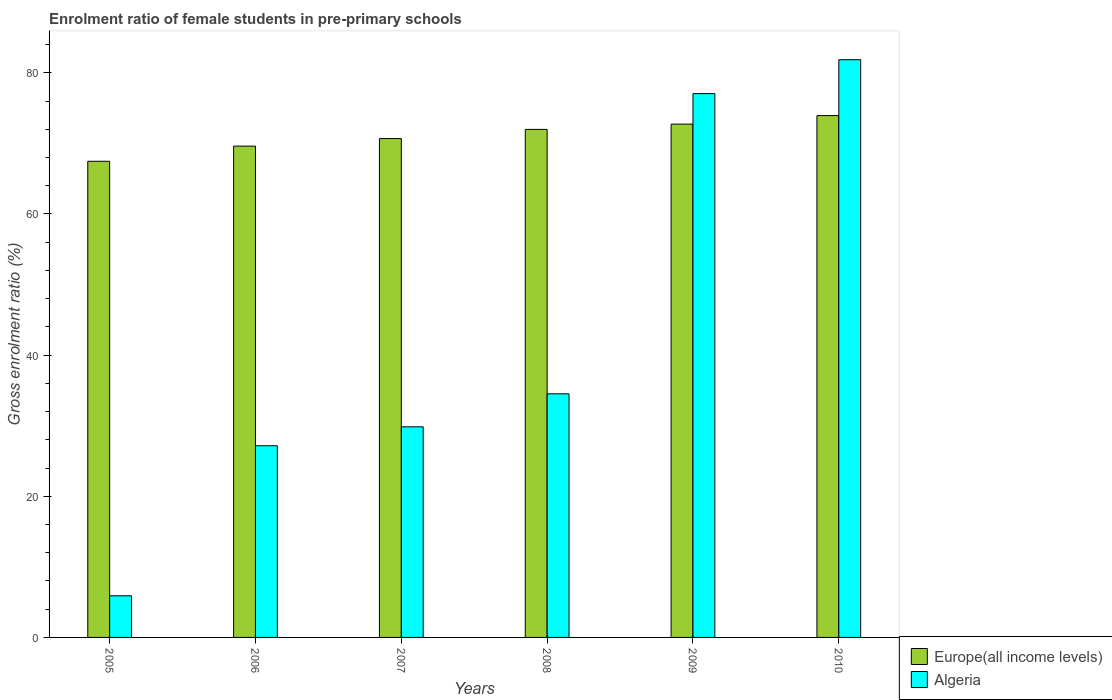How many different coloured bars are there?
Offer a terse response. 2. How many groups of bars are there?
Keep it short and to the point. 6. How many bars are there on the 2nd tick from the right?
Offer a terse response. 2. What is the enrolment ratio of female students in pre-primary schools in Algeria in 2006?
Give a very brief answer. 27.16. Across all years, what is the maximum enrolment ratio of female students in pre-primary schools in Europe(all income levels)?
Make the answer very short. 73.94. Across all years, what is the minimum enrolment ratio of female students in pre-primary schools in Europe(all income levels)?
Your answer should be compact. 67.47. In which year was the enrolment ratio of female students in pre-primary schools in Algeria maximum?
Provide a succinct answer. 2010. In which year was the enrolment ratio of female students in pre-primary schools in Algeria minimum?
Ensure brevity in your answer.  2005. What is the total enrolment ratio of female students in pre-primary schools in Algeria in the graph?
Ensure brevity in your answer.  256.34. What is the difference between the enrolment ratio of female students in pre-primary schools in Europe(all income levels) in 2007 and that in 2008?
Keep it short and to the point. -1.3. What is the difference between the enrolment ratio of female students in pre-primary schools in Europe(all income levels) in 2008 and the enrolment ratio of female students in pre-primary schools in Algeria in 2009?
Make the answer very short. -5.07. What is the average enrolment ratio of female students in pre-primary schools in Europe(all income levels) per year?
Give a very brief answer. 71.07. In the year 2010, what is the difference between the enrolment ratio of female students in pre-primary schools in Algeria and enrolment ratio of female students in pre-primary schools in Europe(all income levels)?
Offer a terse response. 7.92. In how many years, is the enrolment ratio of female students in pre-primary schools in Algeria greater than 8 %?
Offer a terse response. 5. What is the ratio of the enrolment ratio of female students in pre-primary schools in Europe(all income levels) in 2005 to that in 2008?
Your answer should be very brief. 0.94. Is the enrolment ratio of female students in pre-primary schools in Algeria in 2005 less than that in 2007?
Offer a very short reply. Yes. What is the difference between the highest and the second highest enrolment ratio of female students in pre-primary schools in Europe(all income levels)?
Keep it short and to the point. 1.21. What is the difference between the highest and the lowest enrolment ratio of female students in pre-primary schools in Europe(all income levels)?
Provide a short and direct response. 6.47. In how many years, is the enrolment ratio of female students in pre-primary schools in Europe(all income levels) greater than the average enrolment ratio of female students in pre-primary schools in Europe(all income levels) taken over all years?
Make the answer very short. 3. Is the sum of the enrolment ratio of female students in pre-primary schools in Europe(all income levels) in 2005 and 2006 greater than the maximum enrolment ratio of female students in pre-primary schools in Algeria across all years?
Offer a very short reply. Yes. What does the 2nd bar from the left in 2005 represents?
Keep it short and to the point. Algeria. What does the 1st bar from the right in 2006 represents?
Offer a terse response. Algeria. Are all the bars in the graph horizontal?
Make the answer very short. No. What is the difference between two consecutive major ticks on the Y-axis?
Give a very brief answer. 20. Where does the legend appear in the graph?
Your answer should be compact. Bottom right. How are the legend labels stacked?
Offer a very short reply. Vertical. What is the title of the graph?
Offer a very short reply. Enrolment ratio of female students in pre-primary schools. What is the Gross enrolment ratio (%) in Europe(all income levels) in 2005?
Make the answer very short. 67.47. What is the Gross enrolment ratio (%) in Algeria in 2005?
Make the answer very short. 5.9. What is the Gross enrolment ratio (%) in Europe(all income levels) in 2006?
Offer a terse response. 69.62. What is the Gross enrolment ratio (%) in Algeria in 2006?
Your answer should be compact. 27.16. What is the Gross enrolment ratio (%) in Europe(all income levels) in 2007?
Keep it short and to the point. 70.69. What is the Gross enrolment ratio (%) in Algeria in 2007?
Your response must be concise. 29.84. What is the Gross enrolment ratio (%) of Europe(all income levels) in 2008?
Your answer should be very brief. 71.99. What is the Gross enrolment ratio (%) of Algeria in 2008?
Give a very brief answer. 34.52. What is the Gross enrolment ratio (%) in Europe(all income levels) in 2009?
Ensure brevity in your answer.  72.73. What is the Gross enrolment ratio (%) in Algeria in 2009?
Ensure brevity in your answer.  77.06. What is the Gross enrolment ratio (%) in Europe(all income levels) in 2010?
Offer a terse response. 73.94. What is the Gross enrolment ratio (%) in Algeria in 2010?
Keep it short and to the point. 81.86. Across all years, what is the maximum Gross enrolment ratio (%) in Europe(all income levels)?
Ensure brevity in your answer.  73.94. Across all years, what is the maximum Gross enrolment ratio (%) of Algeria?
Provide a short and direct response. 81.86. Across all years, what is the minimum Gross enrolment ratio (%) of Europe(all income levels)?
Your answer should be compact. 67.47. Across all years, what is the minimum Gross enrolment ratio (%) in Algeria?
Make the answer very short. 5.9. What is the total Gross enrolment ratio (%) of Europe(all income levels) in the graph?
Make the answer very short. 426.44. What is the total Gross enrolment ratio (%) of Algeria in the graph?
Give a very brief answer. 256.34. What is the difference between the Gross enrolment ratio (%) in Europe(all income levels) in 2005 and that in 2006?
Keep it short and to the point. -2.15. What is the difference between the Gross enrolment ratio (%) in Algeria in 2005 and that in 2006?
Keep it short and to the point. -21.26. What is the difference between the Gross enrolment ratio (%) in Europe(all income levels) in 2005 and that in 2007?
Offer a terse response. -3.22. What is the difference between the Gross enrolment ratio (%) in Algeria in 2005 and that in 2007?
Provide a succinct answer. -23.95. What is the difference between the Gross enrolment ratio (%) in Europe(all income levels) in 2005 and that in 2008?
Provide a short and direct response. -4.52. What is the difference between the Gross enrolment ratio (%) of Algeria in 2005 and that in 2008?
Ensure brevity in your answer.  -28.62. What is the difference between the Gross enrolment ratio (%) of Europe(all income levels) in 2005 and that in 2009?
Provide a short and direct response. -5.26. What is the difference between the Gross enrolment ratio (%) of Algeria in 2005 and that in 2009?
Offer a terse response. -71.16. What is the difference between the Gross enrolment ratio (%) in Europe(all income levels) in 2005 and that in 2010?
Offer a terse response. -6.47. What is the difference between the Gross enrolment ratio (%) in Algeria in 2005 and that in 2010?
Your answer should be compact. -75.96. What is the difference between the Gross enrolment ratio (%) in Europe(all income levels) in 2006 and that in 2007?
Provide a short and direct response. -1.07. What is the difference between the Gross enrolment ratio (%) in Algeria in 2006 and that in 2007?
Your answer should be compact. -2.68. What is the difference between the Gross enrolment ratio (%) in Europe(all income levels) in 2006 and that in 2008?
Offer a terse response. -2.37. What is the difference between the Gross enrolment ratio (%) in Algeria in 2006 and that in 2008?
Provide a short and direct response. -7.36. What is the difference between the Gross enrolment ratio (%) of Europe(all income levels) in 2006 and that in 2009?
Your answer should be compact. -3.12. What is the difference between the Gross enrolment ratio (%) of Algeria in 2006 and that in 2009?
Your answer should be compact. -49.9. What is the difference between the Gross enrolment ratio (%) of Europe(all income levels) in 2006 and that in 2010?
Ensure brevity in your answer.  -4.33. What is the difference between the Gross enrolment ratio (%) in Algeria in 2006 and that in 2010?
Make the answer very short. -54.7. What is the difference between the Gross enrolment ratio (%) of Europe(all income levels) in 2007 and that in 2008?
Your answer should be compact. -1.3. What is the difference between the Gross enrolment ratio (%) of Algeria in 2007 and that in 2008?
Your response must be concise. -4.67. What is the difference between the Gross enrolment ratio (%) of Europe(all income levels) in 2007 and that in 2009?
Provide a short and direct response. -2.05. What is the difference between the Gross enrolment ratio (%) in Algeria in 2007 and that in 2009?
Your answer should be compact. -47.21. What is the difference between the Gross enrolment ratio (%) in Europe(all income levels) in 2007 and that in 2010?
Give a very brief answer. -3.25. What is the difference between the Gross enrolment ratio (%) of Algeria in 2007 and that in 2010?
Provide a short and direct response. -52.02. What is the difference between the Gross enrolment ratio (%) in Europe(all income levels) in 2008 and that in 2009?
Ensure brevity in your answer.  -0.75. What is the difference between the Gross enrolment ratio (%) of Algeria in 2008 and that in 2009?
Offer a very short reply. -42.54. What is the difference between the Gross enrolment ratio (%) of Europe(all income levels) in 2008 and that in 2010?
Keep it short and to the point. -1.96. What is the difference between the Gross enrolment ratio (%) of Algeria in 2008 and that in 2010?
Your answer should be very brief. -47.34. What is the difference between the Gross enrolment ratio (%) in Europe(all income levels) in 2009 and that in 2010?
Ensure brevity in your answer.  -1.21. What is the difference between the Gross enrolment ratio (%) of Algeria in 2009 and that in 2010?
Offer a terse response. -4.8. What is the difference between the Gross enrolment ratio (%) in Europe(all income levels) in 2005 and the Gross enrolment ratio (%) in Algeria in 2006?
Provide a short and direct response. 40.31. What is the difference between the Gross enrolment ratio (%) in Europe(all income levels) in 2005 and the Gross enrolment ratio (%) in Algeria in 2007?
Make the answer very short. 37.63. What is the difference between the Gross enrolment ratio (%) in Europe(all income levels) in 2005 and the Gross enrolment ratio (%) in Algeria in 2008?
Your response must be concise. 32.95. What is the difference between the Gross enrolment ratio (%) in Europe(all income levels) in 2005 and the Gross enrolment ratio (%) in Algeria in 2009?
Make the answer very short. -9.59. What is the difference between the Gross enrolment ratio (%) of Europe(all income levels) in 2005 and the Gross enrolment ratio (%) of Algeria in 2010?
Your answer should be compact. -14.39. What is the difference between the Gross enrolment ratio (%) in Europe(all income levels) in 2006 and the Gross enrolment ratio (%) in Algeria in 2007?
Provide a short and direct response. 39.77. What is the difference between the Gross enrolment ratio (%) of Europe(all income levels) in 2006 and the Gross enrolment ratio (%) of Algeria in 2008?
Your answer should be very brief. 35.1. What is the difference between the Gross enrolment ratio (%) in Europe(all income levels) in 2006 and the Gross enrolment ratio (%) in Algeria in 2009?
Provide a succinct answer. -7.44. What is the difference between the Gross enrolment ratio (%) of Europe(all income levels) in 2006 and the Gross enrolment ratio (%) of Algeria in 2010?
Keep it short and to the point. -12.24. What is the difference between the Gross enrolment ratio (%) of Europe(all income levels) in 2007 and the Gross enrolment ratio (%) of Algeria in 2008?
Offer a very short reply. 36.17. What is the difference between the Gross enrolment ratio (%) of Europe(all income levels) in 2007 and the Gross enrolment ratio (%) of Algeria in 2009?
Offer a terse response. -6.37. What is the difference between the Gross enrolment ratio (%) in Europe(all income levels) in 2007 and the Gross enrolment ratio (%) in Algeria in 2010?
Your response must be concise. -11.17. What is the difference between the Gross enrolment ratio (%) of Europe(all income levels) in 2008 and the Gross enrolment ratio (%) of Algeria in 2009?
Your answer should be compact. -5.07. What is the difference between the Gross enrolment ratio (%) of Europe(all income levels) in 2008 and the Gross enrolment ratio (%) of Algeria in 2010?
Offer a very short reply. -9.88. What is the difference between the Gross enrolment ratio (%) of Europe(all income levels) in 2009 and the Gross enrolment ratio (%) of Algeria in 2010?
Your answer should be very brief. -9.13. What is the average Gross enrolment ratio (%) of Europe(all income levels) per year?
Keep it short and to the point. 71.07. What is the average Gross enrolment ratio (%) of Algeria per year?
Your response must be concise. 42.72. In the year 2005, what is the difference between the Gross enrolment ratio (%) in Europe(all income levels) and Gross enrolment ratio (%) in Algeria?
Your answer should be compact. 61.57. In the year 2006, what is the difference between the Gross enrolment ratio (%) in Europe(all income levels) and Gross enrolment ratio (%) in Algeria?
Give a very brief answer. 42.46. In the year 2007, what is the difference between the Gross enrolment ratio (%) of Europe(all income levels) and Gross enrolment ratio (%) of Algeria?
Make the answer very short. 40.84. In the year 2008, what is the difference between the Gross enrolment ratio (%) in Europe(all income levels) and Gross enrolment ratio (%) in Algeria?
Ensure brevity in your answer.  37.47. In the year 2009, what is the difference between the Gross enrolment ratio (%) of Europe(all income levels) and Gross enrolment ratio (%) of Algeria?
Offer a terse response. -4.32. In the year 2010, what is the difference between the Gross enrolment ratio (%) in Europe(all income levels) and Gross enrolment ratio (%) in Algeria?
Offer a very short reply. -7.92. What is the ratio of the Gross enrolment ratio (%) of Europe(all income levels) in 2005 to that in 2006?
Give a very brief answer. 0.97. What is the ratio of the Gross enrolment ratio (%) of Algeria in 2005 to that in 2006?
Ensure brevity in your answer.  0.22. What is the ratio of the Gross enrolment ratio (%) in Europe(all income levels) in 2005 to that in 2007?
Provide a short and direct response. 0.95. What is the ratio of the Gross enrolment ratio (%) of Algeria in 2005 to that in 2007?
Your answer should be compact. 0.2. What is the ratio of the Gross enrolment ratio (%) of Europe(all income levels) in 2005 to that in 2008?
Provide a succinct answer. 0.94. What is the ratio of the Gross enrolment ratio (%) of Algeria in 2005 to that in 2008?
Provide a short and direct response. 0.17. What is the ratio of the Gross enrolment ratio (%) of Europe(all income levels) in 2005 to that in 2009?
Make the answer very short. 0.93. What is the ratio of the Gross enrolment ratio (%) in Algeria in 2005 to that in 2009?
Give a very brief answer. 0.08. What is the ratio of the Gross enrolment ratio (%) in Europe(all income levels) in 2005 to that in 2010?
Ensure brevity in your answer.  0.91. What is the ratio of the Gross enrolment ratio (%) in Algeria in 2005 to that in 2010?
Keep it short and to the point. 0.07. What is the ratio of the Gross enrolment ratio (%) in Algeria in 2006 to that in 2007?
Your answer should be compact. 0.91. What is the ratio of the Gross enrolment ratio (%) in Europe(all income levels) in 2006 to that in 2008?
Your response must be concise. 0.97. What is the ratio of the Gross enrolment ratio (%) in Algeria in 2006 to that in 2008?
Your response must be concise. 0.79. What is the ratio of the Gross enrolment ratio (%) in Europe(all income levels) in 2006 to that in 2009?
Make the answer very short. 0.96. What is the ratio of the Gross enrolment ratio (%) in Algeria in 2006 to that in 2009?
Your answer should be very brief. 0.35. What is the ratio of the Gross enrolment ratio (%) of Europe(all income levels) in 2006 to that in 2010?
Provide a short and direct response. 0.94. What is the ratio of the Gross enrolment ratio (%) of Algeria in 2006 to that in 2010?
Make the answer very short. 0.33. What is the ratio of the Gross enrolment ratio (%) in Europe(all income levels) in 2007 to that in 2008?
Provide a short and direct response. 0.98. What is the ratio of the Gross enrolment ratio (%) of Algeria in 2007 to that in 2008?
Ensure brevity in your answer.  0.86. What is the ratio of the Gross enrolment ratio (%) of Europe(all income levels) in 2007 to that in 2009?
Offer a very short reply. 0.97. What is the ratio of the Gross enrolment ratio (%) in Algeria in 2007 to that in 2009?
Ensure brevity in your answer.  0.39. What is the ratio of the Gross enrolment ratio (%) of Europe(all income levels) in 2007 to that in 2010?
Your answer should be very brief. 0.96. What is the ratio of the Gross enrolment ratio (%) in Algeria in 2007 to that in 2010?
Make the answer very short. 0.36. What is the ratio of the Gross enrolment ratio (%) in Algeria in 2008 to that in 2009?
Give a very brief answer. 0.45. What is the ratio of the Gross enrolment ratio (%) in Europe(all income levels) in 2008 to that in 2010?
Ensure brevity in your answer.  0.97. What is the ratio of the Gross enrolment ratio (%) of Algeria in 2008 to that in 2010?
Offer a terse response. 0.42. What is the ratio of the Gross enrolment ratio (%) in Europe(all income levels) in 2009 to that in 2010?
Offer a very short reply. 0.98. What is the ratio of the Gross enrolment ratio (%) in Algeria in 2009 to that in 2010?
Your answer should be compact. 0.94. What is the difference between the highest and the second highest Gross enrolment ratio (%) of Europe(all income levels)?
Your response must be concise. 1.21. What is the difference between the highest and the second highest Gross enrolment ratio (%) in Algeria?
Give a very brief answer. 4.8. What is the difference between the highest and the lowest Gross enrolment ratio (%) in Europe(all income levels)?
Provide a short and direct response. 6.47. What is the difference between the highest and the lowest Gross enrolment ratio (%) of Algeria?
Keep it short and to the point. 75.96. 